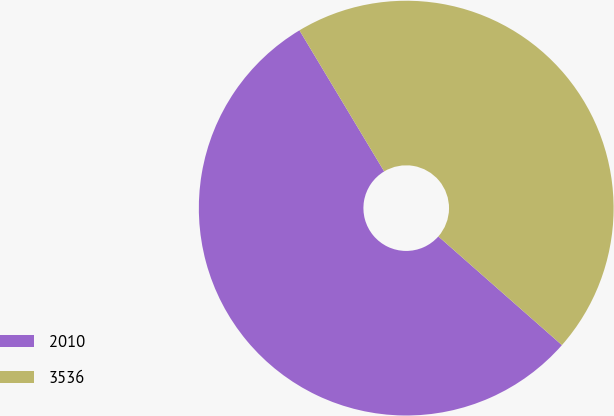<chart> <loc_0><loc_0><loc_500><loc_500><pie_chart><fcel>2010<fcel>3536<nl><fcel>54.91%<fcel>45.09%<nl></chart> 